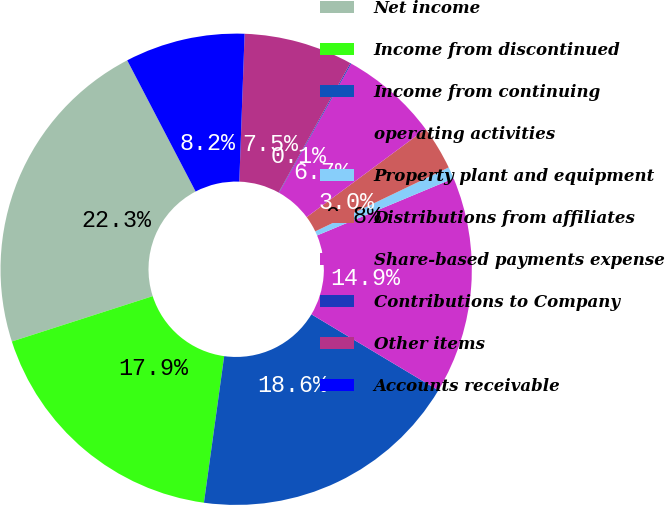Convert chart to OTSL. <chart><loc_0><loc_0><loc_500><loc_500><pie_chart><fcel>Net income<fcel>Income from discontinued<fcel>Income from continuing<fcel>operating activities<fcel>Property plant and equipment<fcel>Distributions from affiliates<fcel>Share-based payments expense<fcel>Contributions to Company<fcel>Other items<fcel>Accounts receivable<nl><fcel>22.31%<fcel>17.86%<fcel>18.6%<fcel>14.89%<fcel>0.81%<fcel>3.03%<fcel>6.74%<fcel>0.07%<fcel>7.48%<fcel>8.22%<nl></chart> 